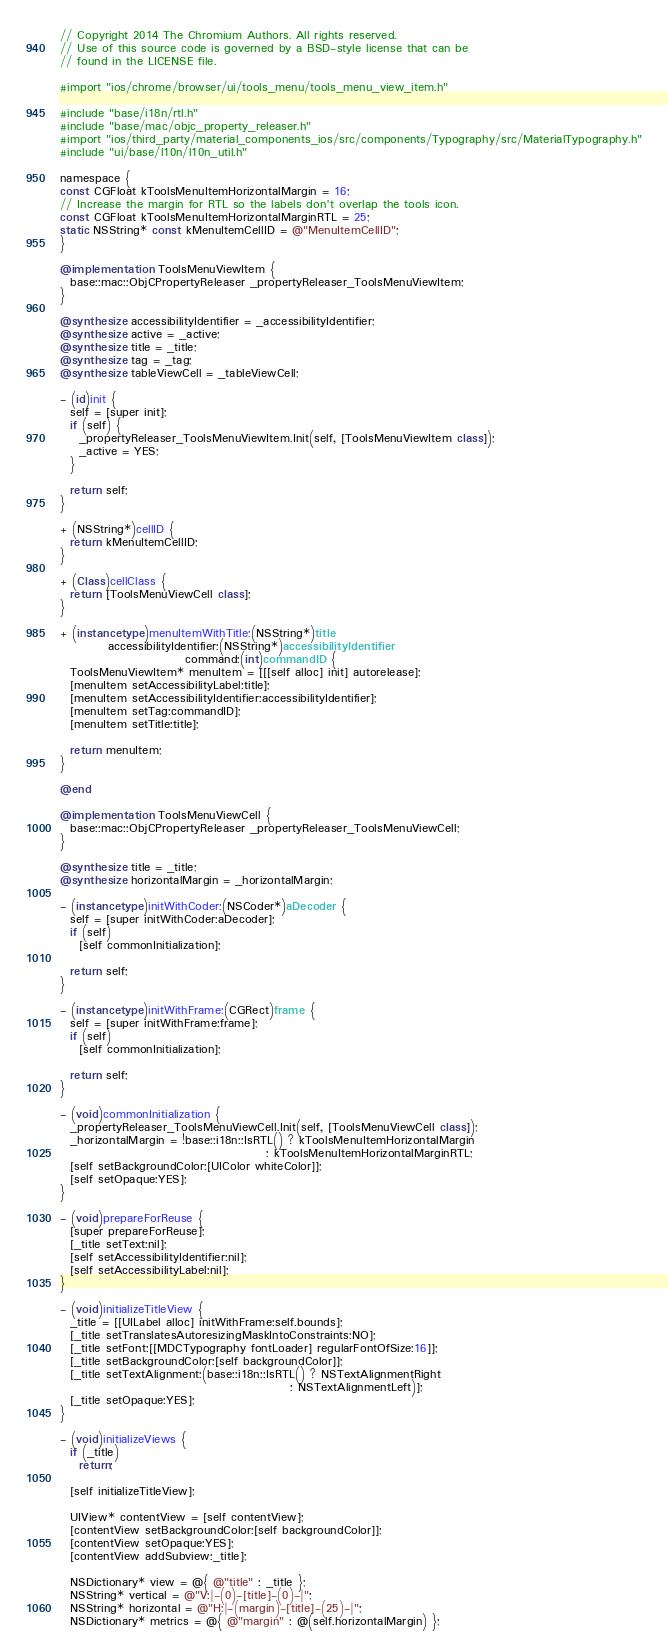Convert code to text. <code><loc_0><loc_0><loc_500><loc_500><_ObjectiveC_>// Copyright 2014 The Chromium Authors. All rights reserved.
// Use of this source code is governed by a BSD-style license that can be
// found in the LICENSE file.

#import "ios/chrome/browser/ui/tools_menu/tools_menu_view_item.h"

#include "base/i18n/rtl.h"
#include "base/mac/objc_property_releaser.h"
#import "ios/third_party/material_components_ios/src/components/Typography/src/MaterialTypography.h"
#include "ui/base/l10n/l10n_util.h"

namespace {
const CGFloat kToolsMenuItemHorizontalMargin = 16;
// Increase the margin for RTL so the labels don't overlap the tools icon.
const CGFloat kToolsMenuItemHorizontalMarginRTL = 25;
static NSString* const kMenuItemCellID = @"MenuItemCellID";
}

@implementation ToolsMenuViewItem {
  base::mac::ObjCPropertyReleaser _propertyReleaser_ToolsMenuViewItem;
}

@synthesize accessibilityIdentifier = _accessibilityIdentifier;
@synthesize active = _active;
@synthesize title = _title;
@synthesize tag = _tag;
@synthesize tableViewCell = _tableViewCell;

- (id)init {
  self = [super init];
  if (self) {
    _propertyReleaser_ToolsMenuViewItem.Init(self, [ToolsMenuViewItem class]);
    _active = YES;
  }

  return self;
}

+ (NSString*)cellID {
  return kMenuItemCellID;
}

+ (Class)cellClass {
  return [ToolsMenuViewCell class];
}

+ (instancetype)menuItemWithTitle:(NSString*)title
          accessibilityIdentifier:(NSString*)accessibilityIdentifier
                          command:(int)commandID {
  ToolsMenuViewItem* menuItem = [[[self alloc] init] autorelease];
  [menuItem setAccessibilityLabel:title];
  [menuItem setAccessibilityIdentifier:accessibilityIdentifier];
  [menuItem setTag:commandID];
  [menuItem setTitle:title];

  return menuItem;
}

@end

@implementation ToolsMenuViewCell {
  base::mac::ObjCPropertyReleaser _propertyReleaser_ToolsMenuViewCell;
}

@synthesize title = _title;
@synthesize horizontalMargin = _horizontalMargin;

- (instancetype)initWithCoder:(NSCoder*)aDecoder {
  self = [super initWithCoder:aDecoder];
  if (self)
    [self commonInitialization];

  return self;
}

- (instancetype)initWithFrame:(CGRect)frame {
  self = [super initWithFrame:frame];
  if (self)
    [self commonInitialization];

  return self;
}

- (void)commonInitialization {
  _propertyReleaser_ToolsMenuViewCell.Init(self, [ToolsMenuViewCell class]);
  _horizontalMargin = !base::i18n::IsRTL() ? kToolsMenuItemHorizontalMargin
                                           : kToolsMenuItemHorizontalMarginRTL;
  [self setBackgroundColor:[UIColor whiteColor]];
  [self setOpaque:YES];
}

- (void)prepareForReuse {
  [super prepareForReuse];
  [_title setText:nil];
  [self setAccessibilityIdentifier:nil];
  [self setAccessibilityLabel:nil];
}

- (void)initializeTitleView {
  _title = [[UILabel alloc] initWithFrame:self.bounds];
  [_title setTranslatesAutoresizingMaskIntoConstraints:NO];
  [_title setFont:[[MDCTypography fontLoader] regularFontOfSize:16]];
  [_title setBackgroundColor:[self backgroundColor]];
  [_title setTextAlignment:(base::i18n::IsRTL() ? NSTextAlignmentRight
                                                : NSTextAlignmentLeft)];
  [_title setOpaque:YES];
}

- (void)initializeViews {
  if (_title)
    return;

  [self initializeTitleView];

  UIView* contentView = [self contentView];
  [contentView setBackgroundColor:[self backgroundColor]];
  [contentView setOpaque:YES];
  [contentView addSubview:_title];

  NSDictionary* view = @{ @"title" : _title };
  NSString* vertical = @"V:|-(0)-[title]-(0)-|";
  NSString* horizontal = @"H:|-(margin)-[title]-(25)-|";
  NSDictionary* metrics = @{ @"margin" : @(self.horizontalMargin) };
</code> 